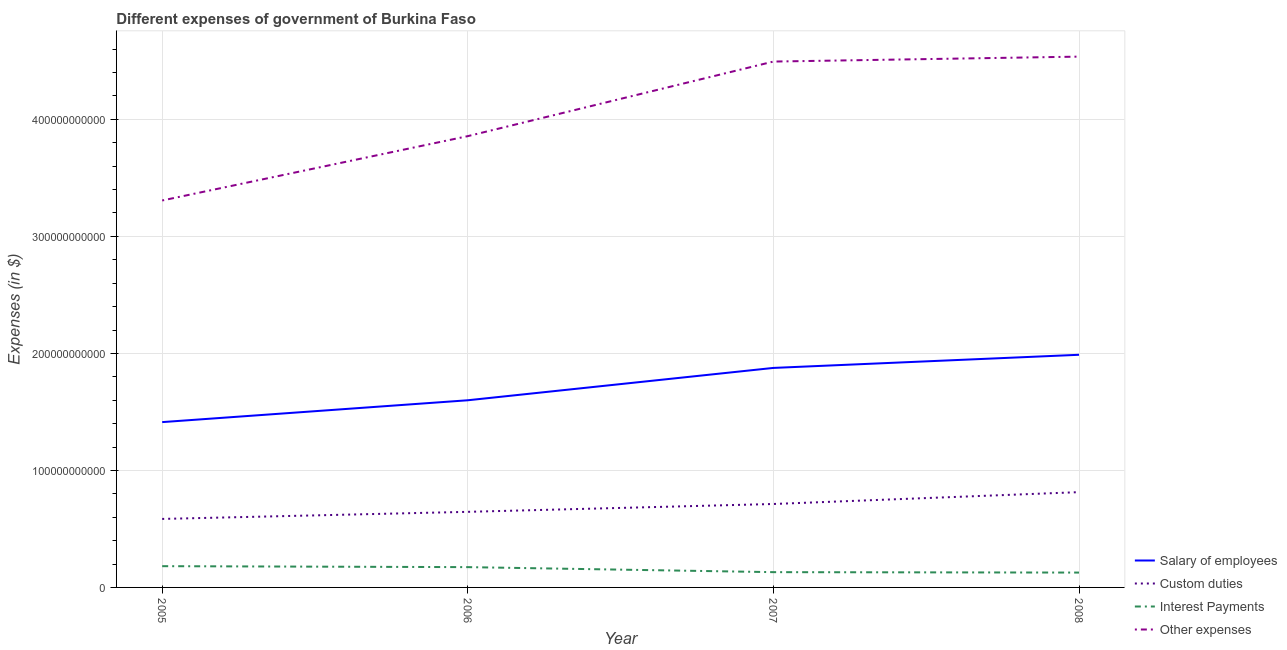What is the amount spent on salary of employees in 2006?
Keep it short and to the point. 1.60e+11. Across all years, what is the maximum amount spent on custom duties?
Provide a succinct answer. 8.14e+1. Across all years, what is the minimum amount spent on other expenses?
Offer a terse response. 3.31e+11. What is the total amount spent on interest payments in the graph?
Make the answer very short. 6.13e+1. What is the difference between the amount spent on other expenses in 2005 and that in 2007?
Your response must be concise. -1.19e+11. What is the difference between the amount spent on custom duties in 2007 and the amount spent on other expenses in 2006?
Your response must be concise. -3.14e+11. What is the average amount spent on other expenses per year?
Your answer should be compact. 4.05e+11. In the year 2005, what is the difference between the amount spent on custom duties and amount spent on interest payments?
Provide a short and direct response. 4.04e+1. What is the ratio of the amount spent on salary of employees in 2006 to that in 2007?
Make the answer very short. 0.85. Is the amount spent on interest payments in 2005 less than that in 2007?
Your response must be concise. No. Is the difference between the amount spent on other expenses in 2006 and 2008 greater than the difference between the amount spent on interest payments in 2006 and 2008?
Provide a short and direct response. No. What is the difference between the highest and the second highest amount spent on salary of employees?
Keep it short and to the point. 1.12e+1. What is the difference between the highest and the lowest amount spent on salary of employees?
Keep it short and to the point. 5.75e+1. Is it the case that in every year, the sum of the amount spent on salary of employees and amount spent on custom duties is greater than the amount spent on interest payments?
Your answer should be compact. Yes. Is the amount spent on other expenses strictly greater than the amount spent on salary of employees over the years?
Offer a very short reply. Yes. How many years are there in the graph?
Ensure brevity in your answer.  4. What is the difference between two consecutive major ticks on the Y-axis?
Offer a terse response. 1.00e+11. Does the graph contain any zero values?
Offer a terse response. No. How are the legend labels stacked?
Provide a short and direct response. Vertical. What is the title of the graph?
Keep it short and to the point. Different expenses of government of Burkina Faso. What is the label or title of the X-axis?
Keep it short and to the point. Year. What is the label or title of the Y-axis?
Give a very brief answer. Expenses (in $). What is the Expenses (in $) in Salary of employees in 2005?
Offer a terse response. 1.41e+11. What is the Expenses (in $) in Custom duties in 2005?
Keep it short and to the point. 5.85e+1. What is the Expenses (in $) of Interest Payments in 2005?
Your answer should be compact. 1.82e+1. What is the Expenses (in $) of Other expenses in 2005?
Give a very brief answer. 3.31e+11. What is the Expenses (in $) of Salary of employees in 2006?
Offer a terse response. 1.60e+11. What is the Expenses (in $) in Custom duties in 2006?
Provide a succinct answer. 6.46e+1. What is the Expenses (in $) in Interest Payments in 2006?
Provide a short and direct response. 1.73e+1. What is the Expenses (in $) in Other expenses in 2006?
Make the answer very short. 3.86e+11. What is the Expenses (in $) in Salary of employees in 2007?
Your response must be concise. 1.88e+11. What is the Expenses (in $) of Custom duties in 2007?
Your response must be concise. 7.13e+1. What is the Expenses (in $) of Interest Payments in 2007?
Make the answer very short. 1.31e+1. What is the Expenses (in $) of Other expenses in 2007?
Ensure brevity in your answer.  4.49e+11. What is the Expenses (in $) in Salary of employees in 2008?
Give a very brief answer. 1.99e+11. What is the Expenses (in $) of Custom duties in 2008?
Keep it short and to the point. 8.14e+1. What is the Expenses (in $) of Interest Payments in 2008?
Give a very brief answer. 1.27e+1. What is the Expenses (in $) of Other expenses in 2008?
Your response must be concise. 4.54e+11. Across all years, what is the maximum Expenses (in $) in Salary of employees?
Provide a succinct answer. 1.99e+11. Across all years, what is the maximum Expenses (in $) of Custom duties?
Offer a terse response. 8.14e+1. Across all years, what is the maximum Expenses (in $) in Interest Payments?
Your response must be concise. 1.82e+1. Across all years, what is the maximum Expenses (in $) in Other expenses?
Your response must be concise. 4.54e+11. Across all years, what is the minimum Expenses (in $) of Salary of employees?
Your response must be concise. 1.41e+11. Across all years, what is the minimum Expenses (in $) in Custom duties?
Provide a short and direct response. 5.85e+1. Across all years, what is the minimum Expenses (in $) in Interest Payments?
Your answer should be very brief. 1.27e+1. Across all years, what is the minimum Expenses (in $) in Other expenses?
Provide a short and direct response. 3.31e+11. What is the total Expenses (in $) of Salary of employees in the graph?
Make the answer very short. 6.88e+11. What is the total Expenses (in $) of Custom duties in the graph?
Make the answer very short. 2.76e+11. What is the total Expenses (in $) of Interest Payments in the graph?
Provide a succinct answer. 6.13e+1. What is the total Expenses (in $) in Other expenses in the graph?
Your answer should be very brief. 1.62e+12. What is the difference between the Expenses (in $) of Salary of employees in 2005 and that in 2006?
Ensure brevity in your answer.  -1.87e+1. What is the difference between the Expenses (in $) in Custom duties in 2005 and that in 2006?
Offer a very short reply. -6.06e+09. What is the difference between the Expenses (in $) of Interest Payments in 2005 and that in 2006?
Your answer should be compact. 8.22e+08. What is the difference between the Expenses (in $) of Other expenses in 2005 and that in 2006?
Make the answer very short. -5.50e+1. What is the difference between the Expenses (in $) in Salary of employees in 2005 and that in 2007?
Make the answer very short. -4.63e+1. What is the difference between the Expenses (in $) of Custom duties in 2005 and that in 2007?
Make the answer very short. -1.28e+1. What is the difference between the Expenses (in $) of Interest Payments in 2005 and that in 2007?
Provide a succinct answer. 5.12e+09. What is the difference between the Expenses (in $) of Other expenses in 2005 and that in 2007?
Your answer should be very brief. -1.19e+11. What is the difference between the Expenses (in $) of Salary of employees in 2005 and that in 2008?
Make the answer very short. -5.75e+1. What is the difference between the Expenses (in $) in Custom duties in 2005 and that in 2008?
Offer a terse response. -2.29e+1. What is the difference between the Expenses (in $) in Interest Payments in 2005 and that in 2008?
Ensure brevity in your answer.  5.48e+09. What is the difference between the Expenses (in $) in Other expenses in 2005 and that in 2008?
Your response must be concise. -1.23e+11. What is the difference between the Expenses (in $) in Salary of employees in 2006 and that in 2007?
Give a very brief answer. -2.76e+1. What is the difference between the Expenses (in $) in Custom duties in 2006 and that in 2007?
Your answer should be very brief. -6.70e+09. What is the difference between the Expenses (in $) in Interest Payments in 2006 and that in 2007?
Your answer should be compact. 4.29e+09. What is the difference between the Expenses (in $) in Other expenses in 2006 and that in 2007?
Your answer should be very brief. -6.37e+1. What is the difference between the Expenses (in $) of Salary of employees in 2006 and that in 2008?
Offer a very short reply. -3.89e+1. What is the difference between the Expenses (in $) in Custom duties in 2006 and that in 2008?
Provide a short and direct response. -1.68e+1. What is the difference between the Expenses (in $) in Interest Payments in 2006 and that in 2008?
Provide a short and direct response. 4.65e+09. What is the difference between the Expenses (in $) in Other expenses in 2006 and that in 2008?
Ensure brevity in your answer.  -6.80e+1. What is the difference between the Expenses (in $) of Salary of employees in 2007 and that in 2008?
Offer a very short reply. -1.12e+1. What is the difference between the Expenses (in $) of Custom duties in 2007 and that in 2008?
Ensure brevity in your answer.  -1.01e+1. What is the difference between the Expenses (in $) of Interest Payments in 2007 and that in 2008?
Keep it short and to the point. 3.61e+08. What is the difference between the Expenses (in $) of Other expenses in 2007 and that in 2008?
Make the answer very short. -4.22e+09. What is the difference between the Expenses (in $) in Salary of employees in 2005 and the Expenses (in $) in Custom duties in 2006?
Ensure brevity in your answer.  7.67e+1. What is the difference between the Expenses (in $) in Salary of employees in 2005 and the Expenses (in $) in Interest Payments in 2006?
Provide a short and direct response. 1.24e+11. What is the difference between the Expenses (in $) of Salary of employees in 2005 and the Expenses (in $) of Other expenses in 2006?
Your answer should be very brief. -2.44e+11. What is the difference between the Expenses (in $) in Custom duties in 2005 and the Expenses (in $) in Interest Payments in 2006?
Provide a succinct answer. 4.12e+1. What is the difference between the Expenses (in $) in Custom duties in 2005 and the Expenses (in $) in Other expenses in 2006?
Provide a succinct answer. -3.27e+11. What is the difference between the Expenses (in $) in Interest Payments in 2005 and the Expenses (in $) in Other expenses in 2006?
Your answer should be very brief. -3.68e+11. What is the difference between the Expenses (in $) in Salary of employees in 2005 and the Expenses (in $) in Custom duties in 2007?
Keep it short and to the point. 7.00e+1. What is the difference between the Expenses (in $) in Salary of employees in 2005 and the Expenses (in $) in Interest Payments in 2007?
Provide a short and direct response. 1.28e+11. What is the difference between the Expenses (in $) of Salary of employees in 2005 and the Expenses (in $) of Other expenses in 2007?
Give a very brief answer. -3.08e+11. What is the difference between the Expenses (in $) in Custom duties in 2005 and the Expenses (in $) in Interest Payments in 2007?
Give a very brief answer. 4.55e+1. What is the difference between the Expenses (in $) of Custom duties in 2005 and the Expenses (in $) of Other expenses in 2007?
Your response must be concise. -3.91e+11. What is the difference between the Expenses (in $) of Interest Payments in 2005 and the Expenses (in $) of Other expenses in 2007?
Give a very brief answer. -4.31e+11. What is the difference between the Expenses (in $) in Salary of employees in 2005 and the Expenses (in $) in Custom duties in 2008?
Your response must be concise. 5.99e+1. What is the difference between the Expenses (in $) of Salary of employees in 2005 and the Expenses (in $) of Interest Payments in 2008?
Provide a succinct answer. 1.29e+11. What is the difference between the Expenses (in $) of Salary of employees in 2005 and the Expenses (in $) of Other expenses in 2008?
Make the answer very short. -3.12e+11. What is the difference between the Expenses (in $) of Custom duties in 2005 and the Expenses (in $) of Interest Payments in 2008?
Ensure brevity in your answer.  4.58e+1. What is the difference between the Expenses (in $) of Custom duties in 2005 and the Expenses (in $) of Other expenses in 2008?
Provide a short and direct response. -3.95e+11. What is the difference between the Expenses (in $) of Interest Payments in 2005 and the Expenses (in $) of Other expenses in 2008?
Keep it short and to the point. -4.35e+11. What is the difference between the Expenses (in $) in Salary of employees in 2006 and the Expenses (in $) in Custom duties in 2007?
Provide a succinct answer. 8.86e+1. What is the difference between the Expenses (in $) in Salary of employees in 2006 and the Expenses (in $) in Interest Payments in 2007?
Provide a succinct answer. 1.47e+11. What is the difference between the Expenses (in $) of Salary of employees in 2006 and the Expenses (in $) of Other expenses in 2007?
Offer a very short reply. -2.89e+11. What is the difference between the Expenses (in $) in Custom duties in 2006 and the Expenses (in $) in Interest Payments in 2007?
Offer a terse response. 5.15e+1. What is the difference between the Expenses (in $) of Custom duties in 2006 and the Expenses (in $) of Other expenses in 2007?
Your response must be concise. -3.85e+11. What is the difference between the Expenses (in $) in Interest Payments in 2006 and the Expenses (in $) in Other expenses in 2007?
Ensure brevity in your answer.  -4.32e+11. What is the difference between the Expenses (in $) in Salary of employees in 2006 and the Expenses (in $) in Custom duties in 2008?
Make the answer very short. 7.85e+1. What is the difference between the Expenses (in $) in Salary of employees in 2006 and the Expenses (in $) in Interest Payments in 2008?
Your response must be concise. 1.47e+11. What is the difference between the Expenses (in $) in Salary of employees in 2006 and the Expenses (in $) in Other expenses in 2008?
Offer a very short reply. -2.94e+11. What is the difference between the Expenses (in $) of Custom duties in 2006 and the Expenses (in $) of Interest Payments in 2008?
Your answer should be very brief. 5.19e+1. What is the difference between the Expenses (in $) in Custom duties in 2006 and the Expenses (in $) in Other expenses in 2008?
Your answer should be very brief. -3.89e+11. What is the difference between the Expenses (in $) in Interest Payments in 2006 and the Expenses (in $) in Other expenses in 2008?
Ensure brevity in your answer.  -4.36e+11. What is the difference between the Expenses (in $) of Salary of employees in 2007 and the Expenses (in $) of Custom duties in 2008?
Offer a terse response. 1.06e+11. What is the difference between the Expenses (in $) of Salary of employees in 2007 and the Expenses (in $) of Interest Payments in 2008?
Make the answer very short. 1.75e+11. What is the difference between the Expenses (in $) in Salary of employees in 2007 and the Expenses (in $) in Other expenses in 2008?
Your answer should be compact. -2.66e+11. What is the difference between the Expenses (in $) of Custom duties in 2007 and the Expenses (in $) of Interest Payments in 2008?
Provide a succinct answer. 5.86e+1. What is the difference between the Expenses (in $) of Custom duties in 2007 and the Expenses (in $) of Other expenses in 2008?
Your response must be concise. -3.82e+11. What is the difference between the Expenses (in $) in Interest Payments in 2007 and the Expenses (in $) in Other expenses in 2008?
Ensure brevity in your answer.  -4.41e+11. What is the average Expenses (in $) of Salary of employees per year?
Offer a very short reply. 1.72e+11. What is the average Expenses (in $) of Custom duties per year?
Make the answer very short. 6.90e+1. What is the average Expenses (in $) of Interest Payments per year?
Your response must be concise. 1.53e+1. What is the average Expenses (in $) in Other expenses per year?
Offer a terse response. 4.05e+11. In the year 2005, what is the difference between the Expenses (in $) of Salary of employees and Expenses (in $) of Custom duties?
Give a very brief answer. 8.27e+1. In the year 2005, what is the difference between the Expenses (in $) in Salary of employees and Expenses (in $) in Interest Payments?
Make the answer very short. 1.23e+11. In the year 2005, what is the difference between the Expenses (in $) in Salary of employees and Expenses (in $) in Other expenses?
Offer a terse response. -1.89e+11. In the year 2005, what is the difference between the Expenses (in $) of Custom duties and Expenses (in $) of Interest Payments?
Keep it short and to the point. 4.04e+1. In the year 2005, what is the difference between the Expenses (in $) of Custom duties and Expenses (in $) of Other expenses?
Provide a succinct answer. -2.72e+11. In the year 2005, what is the difference between the Expenses (in $) in Interest Payments and Expenses (in $) in Other expenses?
Provide a succinct answer. -3.13e+11. In the year 2006, what is the difference between the Expenses (in $) in Salary of employees and Expenses (in $) in Custom duties?
Give a very brief answer. 9.53e+1. In the year 2006, what is the difference between the Expenses (in $) in Salary of employees and Expenses (in $) in Interest Payments?
Make the answer very short. 1.43e+11. In the year 2006, what is the difference between the Expenses (in $) in Salary of employees and Expenses (in $) in Other expenses?
Provide a succinct answer. -2.26e+11. In the year 2006, what is the difference between the Expenses (in $) of Custom duties and Expenses (in $) of Interest Payments?
Give a very brief answer. 4.73e+1. In the year 2006, what is the difference between the Expenses (in $) of Custom duties and Expenses (in $) of Other expenses?
Your answer should be compact. -3.21e+11. In the year 2006, what is the difference between the Expenses (in $) in Interest Payments and Expenses (in $) in Other expenses?
Your response must be concise. -3.68e+11. In the year 2007, what is the difference between the Expenses (in $) in Salary of employees and Expenses (in $) in Custom duties?
Provide a short and direct response. 1.16e+11. In the year 2007, what is the difference between the Expenses (in $) of Salary of employees and Expenses (in $) of Interest Payments?
Your answer should be very brief. 1.75e+11. In the year 2007, what is the difference between the Expenses (in $) in Salary of employees and Expenses (in $) in Other expenses?
Provide a succinct answer. -2.62e+11. In the year 2007, what is the difference between the Expenses (in $) in Custom duties and Expenses (in $) in Interest Payments?
Your answer should be compact. 5.82e+1. In the year 2007, what is the difference between the Expenses (in $) of Custom duties and Expenses (in $) of Other expenses?
Your answer should be compact. -3.78e+11. In the year 2007, what is the difference between the Expenses (in $) in Interest Payments and Expenses (in $) in Other expenses?
Keep it short and to the point. -4.36e+11. In the year 2008, what is the difference between the Expenses (in $) in Salary of employees and Expenses (in $) in Custom duties?
Offer a terse response. 1.17e+11. In the year 2008, what is the difference between the Expenses (in $) in Salary of employees and Expenses (in $) in Interest Payments?
Make the answer very short. 1.86e+11. In the year 2008, what is the difference between the Expenses (in $) in Salary of employees and Expenses (in $) in Other expenses?
Offer a very short reply. -2.55e+11. In the year 2008, what is the difference between the Expenses (in $) of Custom duties and Expenses (in $) of Interest Payments?
Offer a terse response. 6.87e+1. In the year 2008, what is the difference between the Expenses (in $) of Custom duties and Expenses (in $) of Other expenses?
Your answer should be compact. -3.72e+11. In the year 2008, what is the difference between the Expenses (in $) in Interest Payments and Expenses (in $) in Other expenses?
Ensure brevity in your answer.  -4.41e+11. What is the ratio of the Expenses (in $) in Salary of employees in 2005 to that in 2006?
Offer a terse response. 0.88. What is the ratio of the Expenses (in $) of Custom duties in 2005 to that in 2006?
Your response must be concise. 0.91. What is the ratio of the Expenses (in $) of Interest Payments in 2005 to that in 2006?
Your answer should be compact. 1.05. What is the ratio of the Expenses (in $) in Other expenses in 2005 to that in 2006?
Your answer should be compact. 0.86. What is the ratio of the Expenses (in $) of Salary of employees in 2005 to that in 2007?
Provide a short and direct response. 0.75. What is the ratio of the Expenses (in $) of Custom duties in 2005 to that in 2007?
Offer a terse response. 0.82. What is the ratio of the Expenses (in $) in Interest Payments in 2005 to that in 2007?
Your response must be concise. 1.39. What is the ratio of the Expenses (in $) of Other expenses in 2005 to that in 2007?
Ensure brevity in your answer.  0.74. What is the ratio of the Expenses (in $) in Salary of employees in 2005 to that in 2008?
Give a very brief answer. 0.71. What is the ratio of the Expenses (in $) in Custom duties in 2005 to that in 2008?
Your answer should be compact. 0.72. What is the ratio of the Expenses (in $) of Interest Payments in 2005 to that in 2008?
Provide a short and direct response. 1.43. What is the ratio of the Expenses (in $) in Other expenses in 2005 to that in 2008?
Your answer should be very brief. 0.73. What is the ratio of the Expenses (in $) in Salary of employees in 2006 to that in 2007?
Offer a terse response. 0.85. What is the ratio of the Expenses (in $) of Custom duties in 2006 to that in 2007?
Offer a terse response. 0.91. What is the ratio of the Expenses (in $) in Interest Payments in 2006 to that in 2007?
Keep it short and to the point. 1.33. What is the ratio of the Expenses (in $) of Other expenses in 2006 to that in 2007?
Offer a very short reply. 0.86. What is the ratio of the Expenses (in $) in Salary of employees in 2006 to that in 2008?
Keep it short and to the point. 0.8. What is the ratio of the Expenses (in $) of Custom duties in 2006 to that in 2008?
Your response must be concise. 0.79. What is the ratio of the Expenses (in $) in Interest Payments in 2006 to that in 2008?
Make the answer very short. 1.37. What is the ratio of the Expenses (in $) in Other expenses in 2006 to that in 2008?
Offer a very short reply. 0.85. What is the ratio of the Expenses (in $) of Salary of employees in 2007 to that in 2008?
Your response must be concise. 0.94. What is the ratio of the Expenses (in $) in Custom duties in 2007 to that in 2008?
Provide a short and direct response. 0.88. What is the ratio of the Expenses (in $) of Interest Payments in 2007 to that in 2008?
Ensure brevity in your answer.  1.03. What is the ratio of the Expenses (in $) in Other expenses in 2007 to that in 2008?
Provide a short and direct response. 0.99. What is the difference between the highest and the second highest Expenses (in $) in Salary of employees?
Your response must be concise. 1.12e+1. What is the difference between the highest and the second highest Expenses (in $) in Custom duties?
Your answer should be compact. 1.01e+1. What is the difference between the highest and the second highest Expenses (in $) of Interest Payments?
Provide a succinct answer. 8.22e+08. What is the difference between the highest and the second highest Expenses (in $) in Other expenses?
Ensure brevity in your answer.  4.22e+09. What is the difference between the highest and the lowest Expenses (in $) of Salary of employees?
Your answer should be compact. 5.75e+1. What is the difference between the highest and the lowest Expenses (in $) in Custom duties?
Offer a very short reply. 2.29e+1. What is the difference between the highest and the lowest Expenses (in $) of Interest Payments?
Keep it short and to the point. 5.48e+09. What is the difference between the highest and the lowest Expenses (in $) in Other expenses?
Keep it short and to the point. 1.23e+11. 